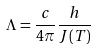<formula> <loc_0><loc_0><loc_500><loc_500>\Lambda = \frac { c } { 4 \pi } \frac { h } { J ( T ) }</formula> 